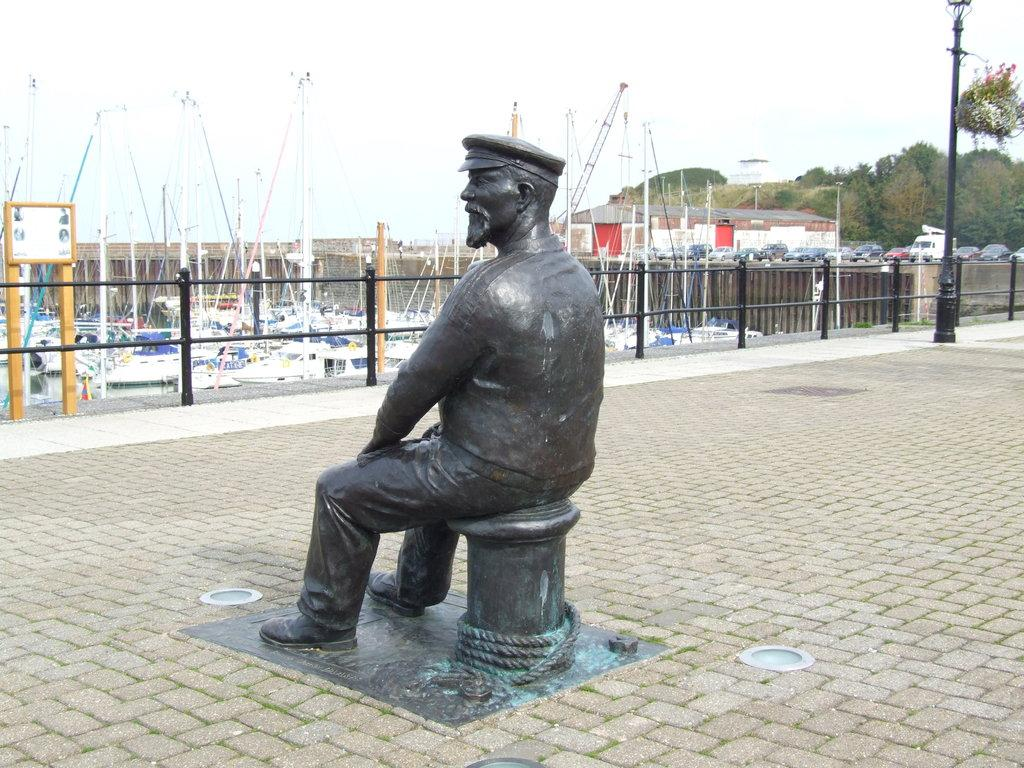What is the main subject in the image? There is a statue in the image. What can be seen surrounding the statue? There is fencing in the image. What other objects are visible in the image? There are boats, poles, and trees in the image. What type of lace can be seen on the statue's clothing in the image? There is no lace present on the statue's clothing in the image. 